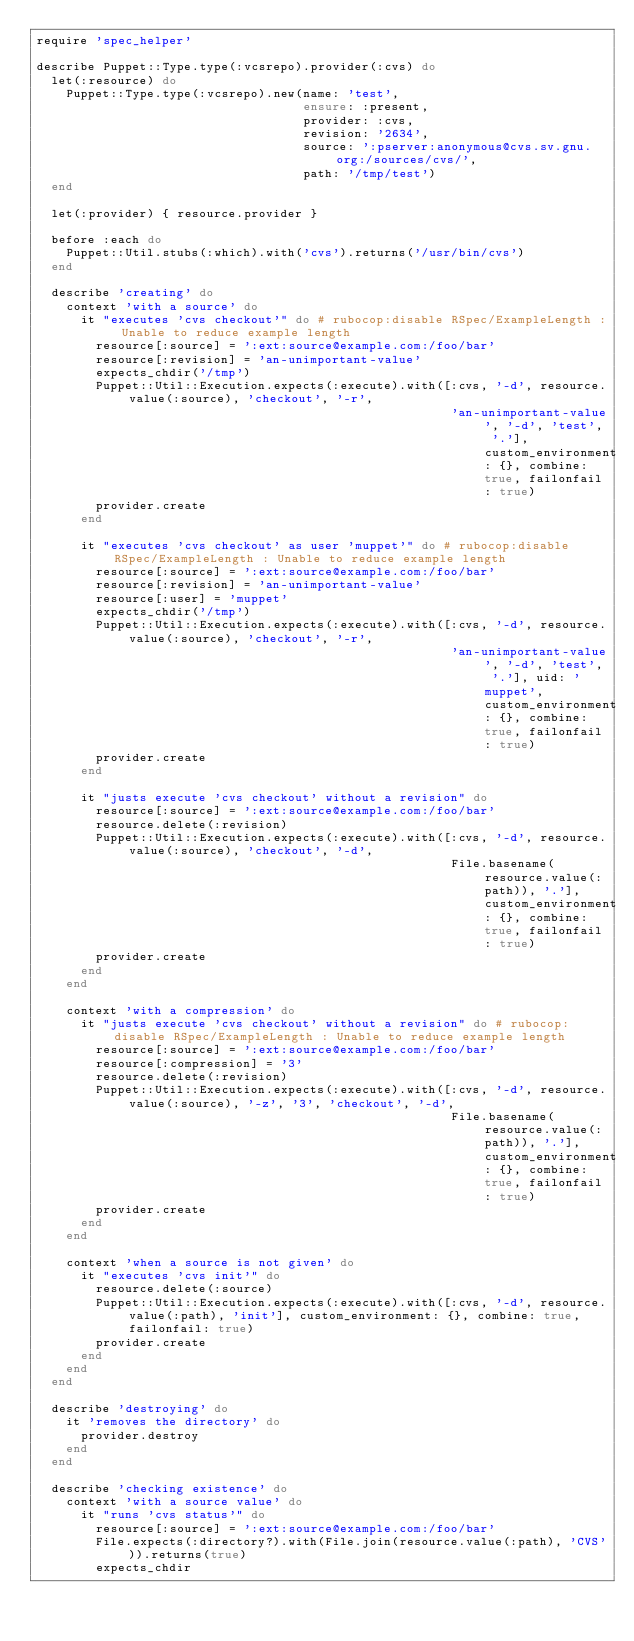Convert code to text. <code><loc_0><loc_0><loc_500><loc_500><_Ruby_>require 'spec_helper'

describe Puppet::Type.type(:vcsrepo).provider(:cvs) do
  let(:resource) do
    Puppet::Type.type(:vcsrepo).new(name: 'test',
                                    ensure: :present,
                                    provider: :cvs,
                                    revision: '2634',
                                    source: ':pserver:anonymous@cvs.sv.gnu.org:/sources/cvs/',
                                    path: '/tmp/test')
  end

  let(:provider) { resource.provider }

  before :each do
    Puppet::Util.stubs(:which).with('cvs').returns('/usr/bin/cvs')
  end

  describe 'creating' do
    context 'with a source' do
      it "executes 'cvs checkout'" do # rubocop:disable RSpec/ExampleLength : Unable to reduce example length
        resource[:source] = ':ext:source@example.com:/foo/bar'
        resource[:revision] = 'an-unimportant-value'
        expects_chdir('/tmp')
        Puppet::Util::Execution.expects(:execute).with([:cvs, '-d', resource.value(:source), 'checkout', '-r',
                                                        'an-unimportant-value', '-d', 'test', '.'], custom_environment: {}, combine: true, failonfail: true)
        provider.create
      end

      it "executes 'cvs checkout' as user 'muppet'" do # rubocop:disable RSpec/ExampleLength : Unable to reduce example length
        resource[:source] = ':ext:source@example.com:/foo/bar'
        resource[:revision] = 'an-unimportant-value'
        resource[:user] = 'muppet'
        expects_chdir('/tmp')
        Puppet::Util::Execution.expects(:execute).with([:cvs, '-d', resource.value(:source), 'checkout', '-r',
                                                        'an-unimportant-value', '-d', 'test', '.'], uid: 'muppet', custom_environment: {}, combine: true, failonfail: true)
        provider.create
      end

      it "justs execute 'cvs checkout' without a revision" do
        resource[:source] = ':ext:source@example.com:/foo/bar'
        resource.delete(:revision)
        Puppet::Util::Execution.expects(:execute).with([:cvs, '-d', resource.value(:source), 'checkout', '-d',
                                                        File.basename(resource.value(:path)), '.'], custom_environment: {}, combine: true, failonfail: true)
        provider.create
      end
    end

    context 'with a compression' do
      it "justs execute 'cvs checkout' without a revision" do # rubocop:disable RSpec/ExampleLength : Unable to reduce example length
        resource[:source] = ':ext:source@example.com:/foo/bar'
        resource[:compression] = '3'
        resource.delete(:revision)
        Puppet::Util::Execution.expects(:execute).with([:cvs, '-d', resource.value(:source), '-z', '3', 'checkout', '-d',
                                                        File.basename(resource.value(:path)), '.'], custom_environment: {}, combine: true, failonfail: true)
        provider.create
      end
    end

    context 'when a source is not given' do
      it "executes 'cvs init'" do
        resource.delete(:source)
        Puppet::Util::Execution.expects(:execute).with([:cvs, '-d', resource.value(:path), 'init'], custom_environment: {}, combine: true, failonfail: true)
        provider.create
      end
    end
  end

  describe 'destroying' do
    it 'removes the directory' do
      provider.destroy
    end
  end

  describe 'checking existence' do
    context 'with a source value' do
      it "runs 'cvs status'" do
        resource[:source] = ':ext:source@example.com:/foo/bar'
        File.expects(:directory?).with(File.join(resource.value(:path), 'CVS')).returns(true)
        expects_chdir</code> 